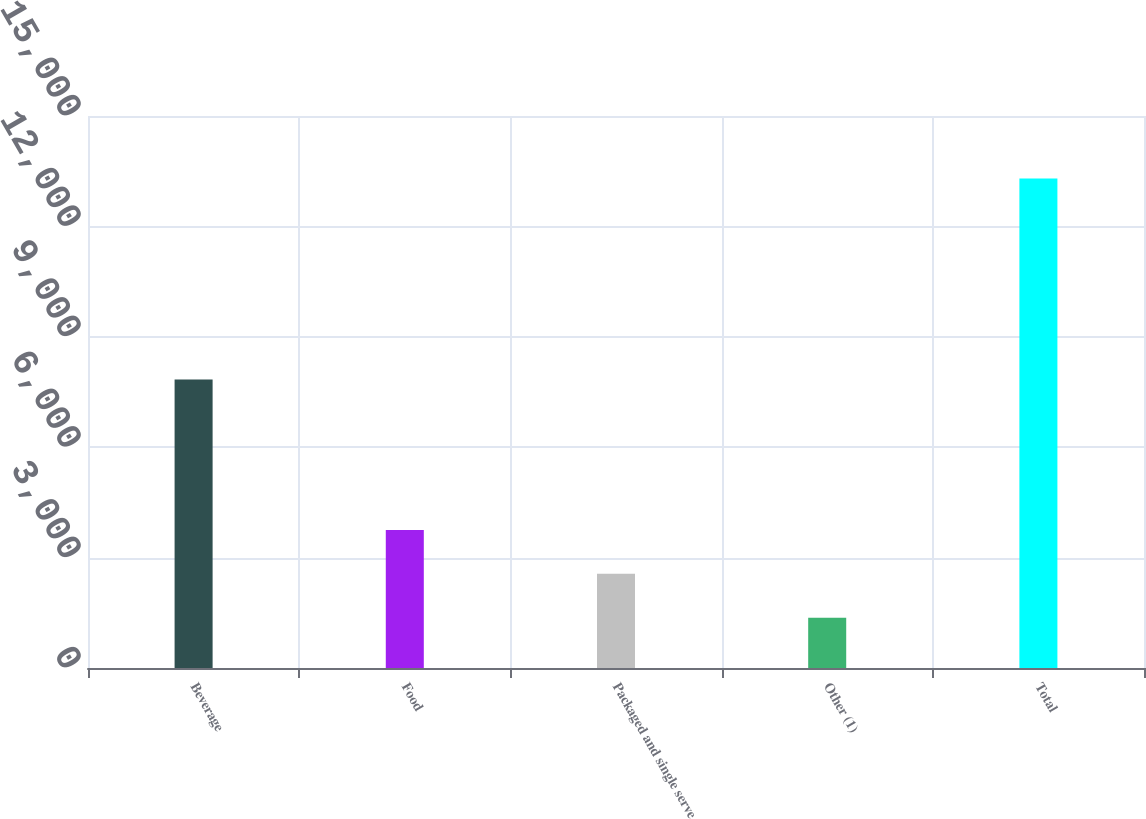Convert chart. <chart><loc_0><loc_0><loc_500><loc_500><bar_chart><fcel>Beverage<fcel>Food<fcel>Packaged and single serve<fcel>Other (1)<fcel>Total<nl><fcel>7838.8<fcel>3753.34<fcel>2560.07<fcel>1366.8<fcel>13299.5<nl></chart> 